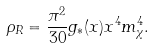Convert formula to latex. <formula><loc_0><loc_0><loc_500><loc_500>\rho _ { R } = \frac { \pi ^ { 2 } } { 3 0 } g _ { * } ( x ) x ^ { 4 } m _ { \chi } ^ { 4 } .</formula> 